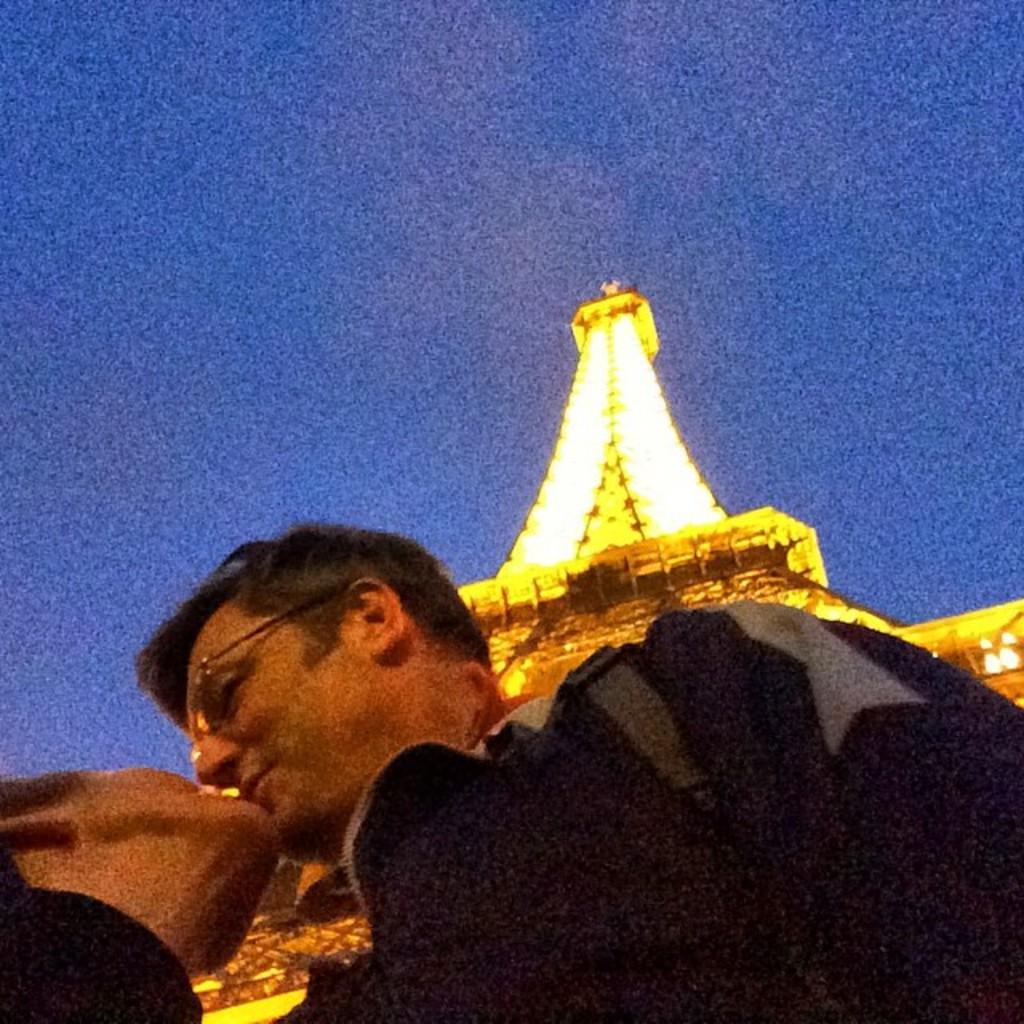Please provide a concise description of this image. It looks like an edited image. We can see there are two people kissing. Behind the people, there is an "Eiffel tower" and the sky. 